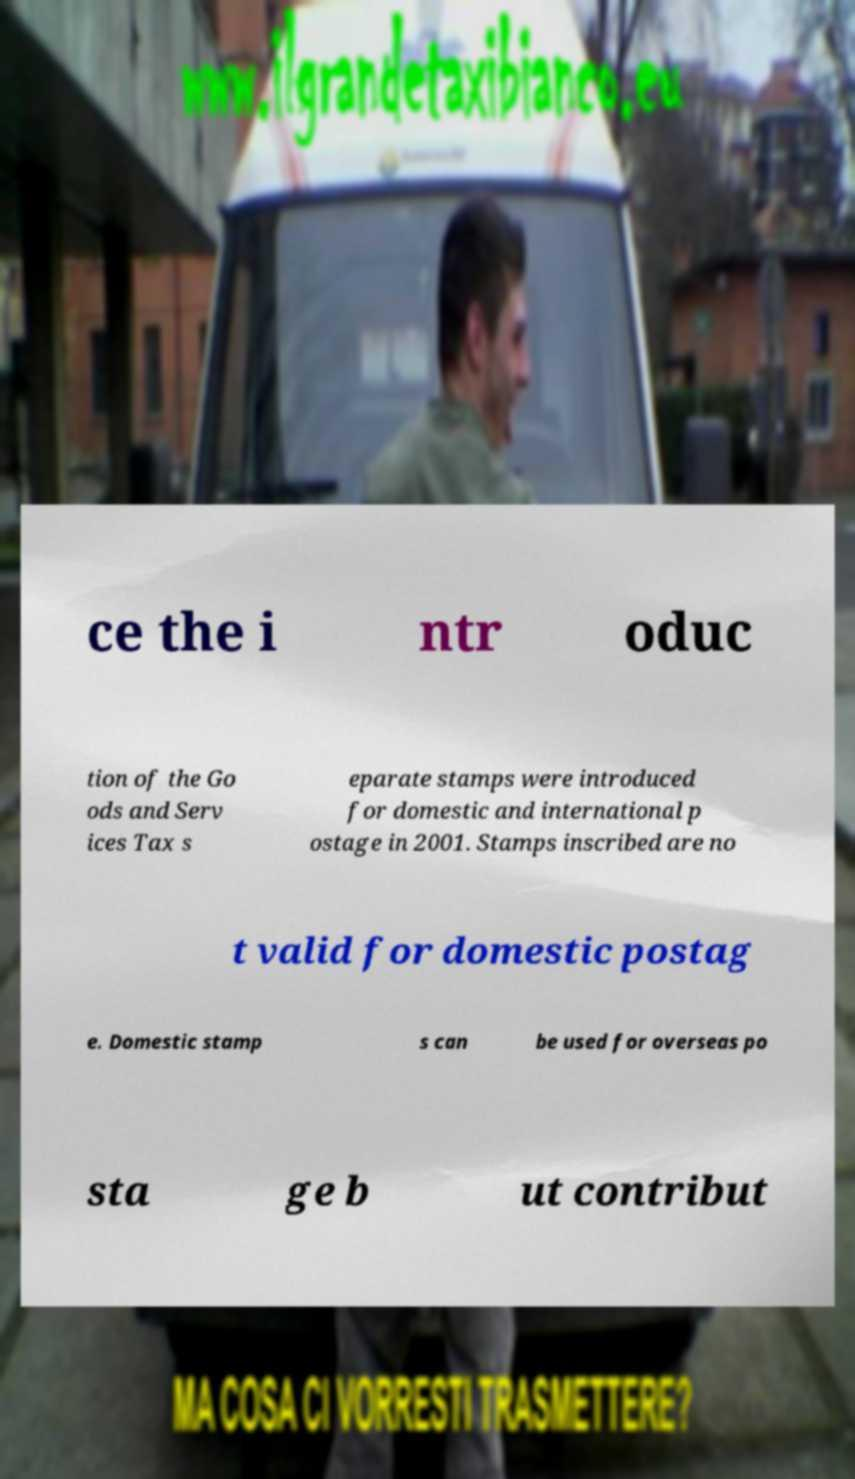What messages or text are displayed in this image? I need them in a readable, typed format. ce the i ntr oduc tion of the Go ods and Serv ices Tax s eparate stamps were introduced for domestic and international p ostage in 2001. Stamps inscribed are no t valid for domestic postag e. Domestic stamp s can be used for overseas po sta ge b ut contribut 